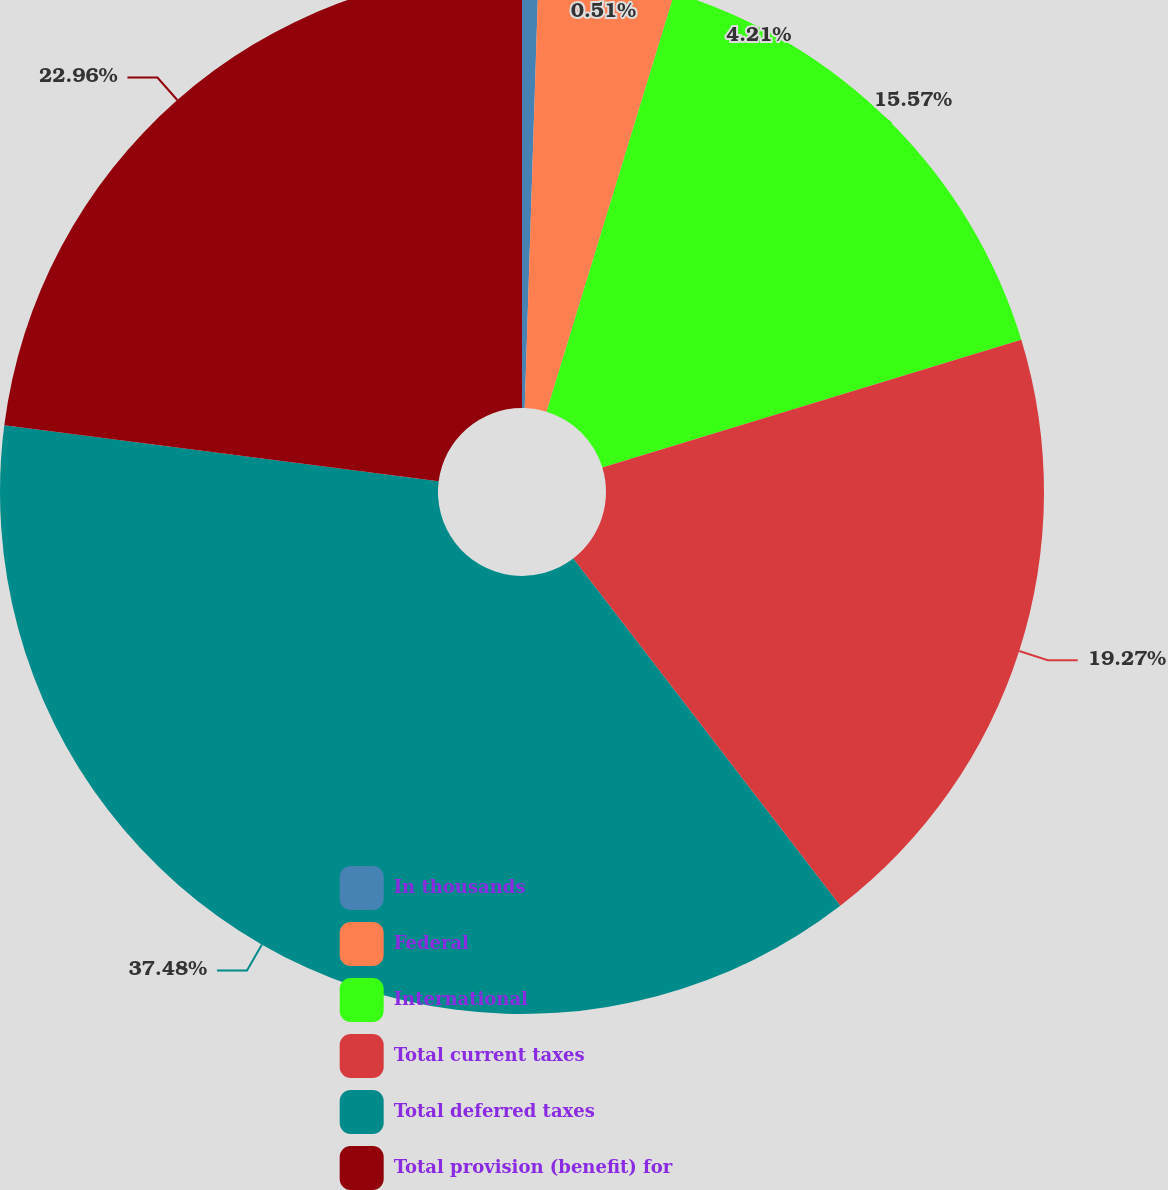<chart> <loc_0><loc_0><loc_500><loc_500><pie_chart><fcel>In thousands<fcel>Federal<fcel>International<fcel>Total current taxes<fcel>Total deferred taxes<fcel>Total provision (benefit) for<nl><fcel>0.51%<fcel>4.21%<fcel>15.57%<fcel>19.27%<fcel>37.47%<fcel>22.96%<nl></chart> 